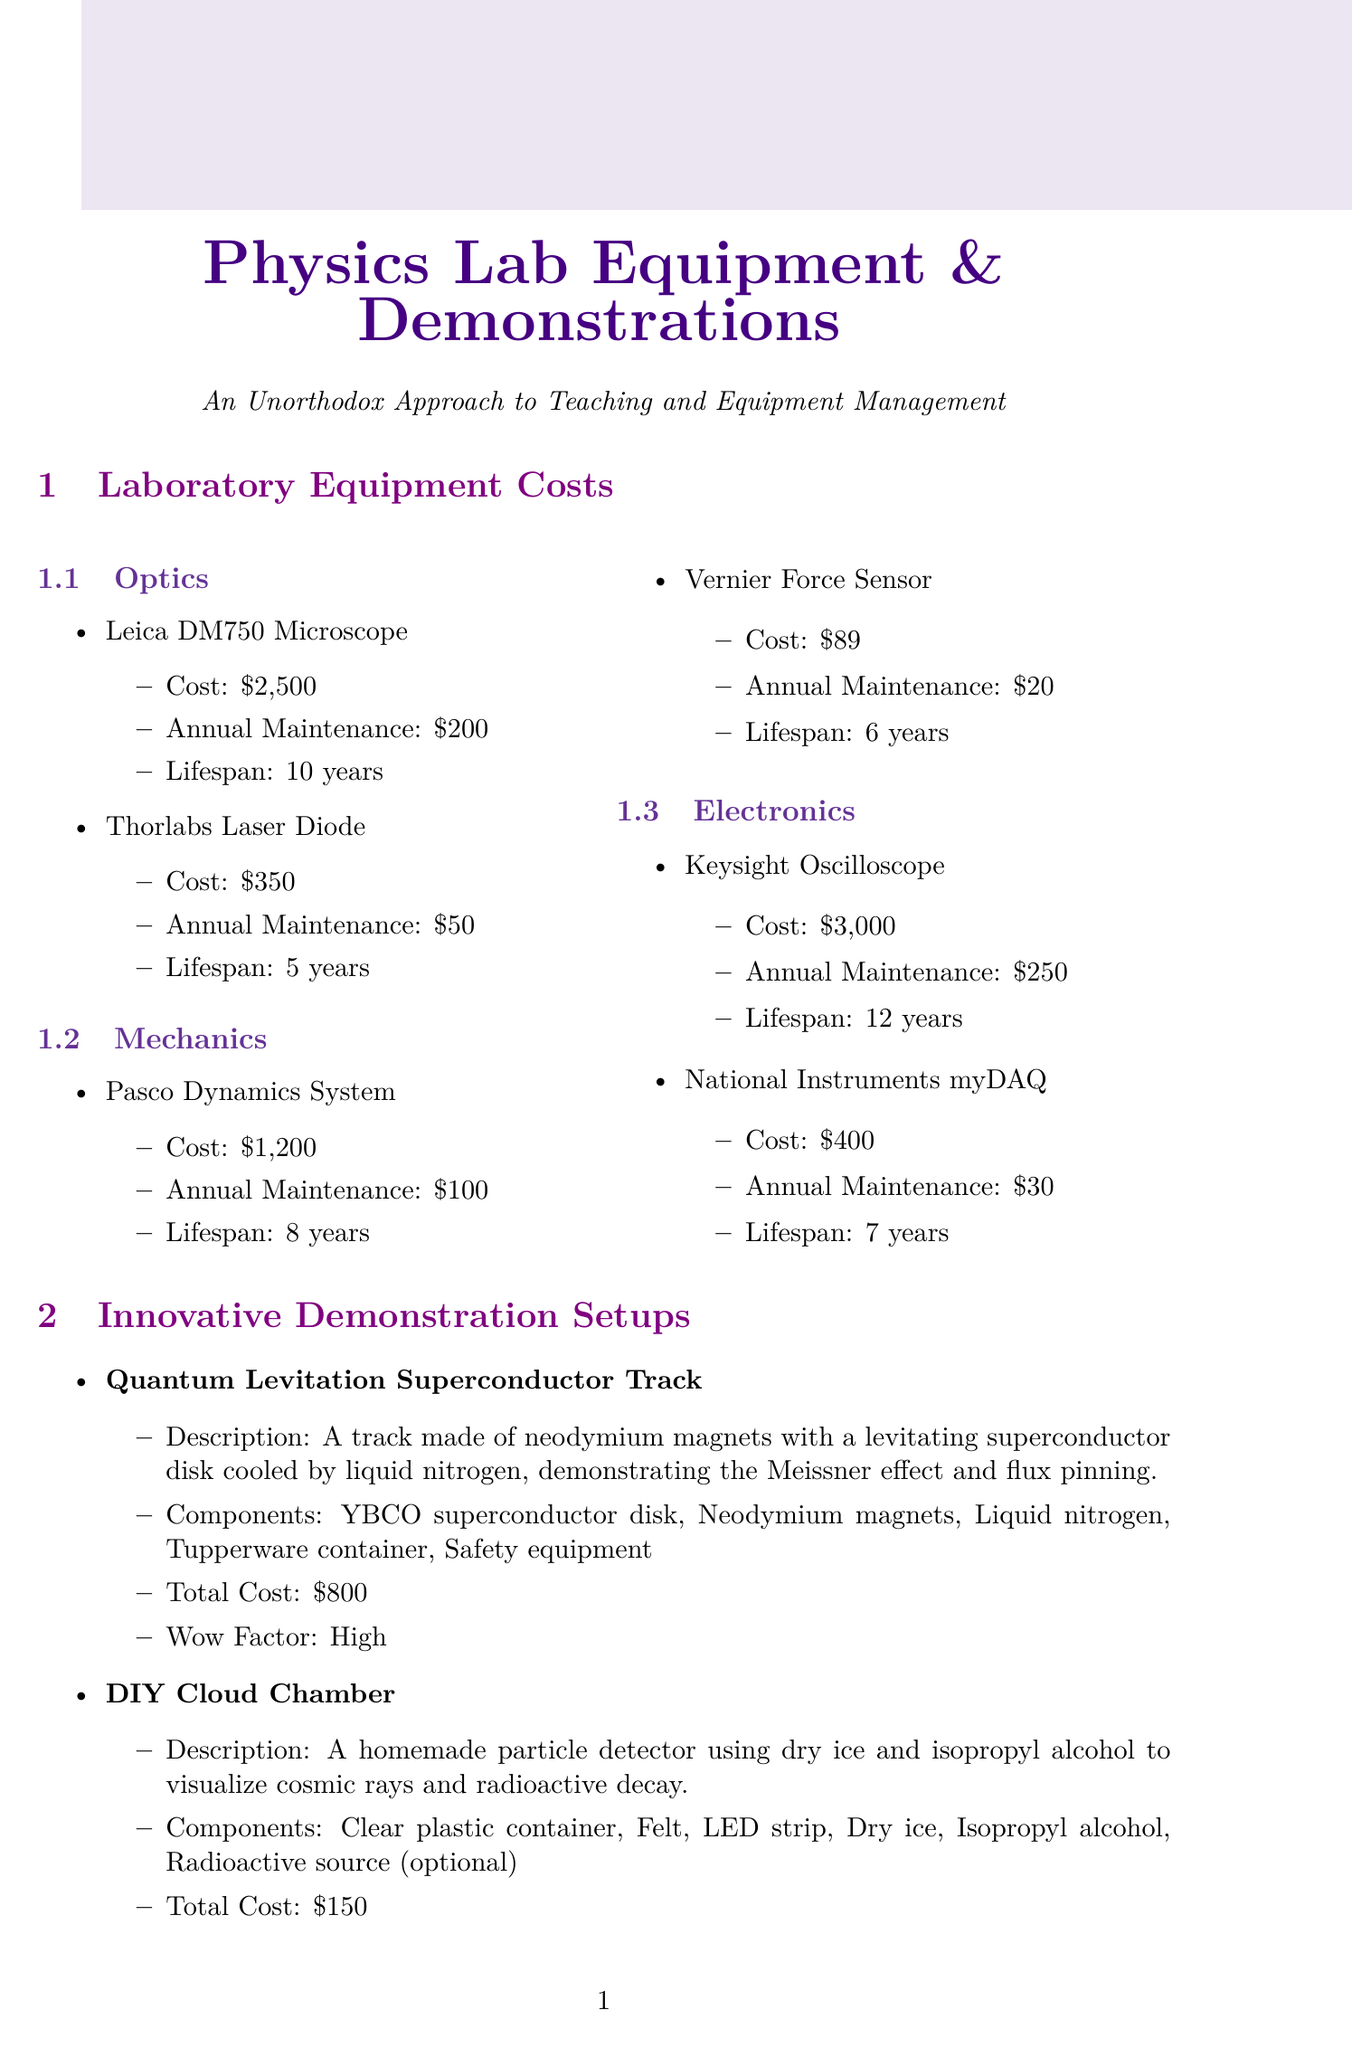What is the cost of the Leica DM750 Microscope? The cost of the Leica DM750 Microscope is listed under the Optics category as $2,500.
Answer: $2,500 What is the wow factor of the Quantum Levitation Superconductor Track? The wow factor is specified as "High" in the description of the demonstration setups.
Answer: High How long is the lifespan of the Keysight Oscilloscope? The lifespan is detailed as 12 years in the Electronics section for the Keysight Oscilloscope.
Answer: 12 years What maintenance practice is recommended for optical instruments? The document lists regular cleaning with lint-free cloths and specialized solutions as a best practice for optical instruments.
Answer: Regular cleaning What is the potential savings from open-source hardware? The potential savings from utilizing open-source designs for custom equipment is expressed as a percentage in the Cost Saving Strategies section.
Answer: 30-70% How much does the DIY Cloud Chamber setup cost? The total cost for the DIY Cloud Chamber setup is explicitly mentioned in its description.
Answer: $150 What equipment is needed for the Physics Karaoke method? The required equipment is specified in the unorthodox teaching methods section, where it lists needed items for executing this method.
Answer: Microphone, Speaker system, Projector for lyrics What strategy involves coordinating with other departments for discounts? The strategy that involves coordination for collective ordering is referred to in the Cost Saving Strategies section.
Answer: Bulk purchasing How many components are used in the Electromagnetic Levitation System? The number of components can be counted in the description of the Electromagnetic Levitation System setup listed in the document.
Answer: 5 